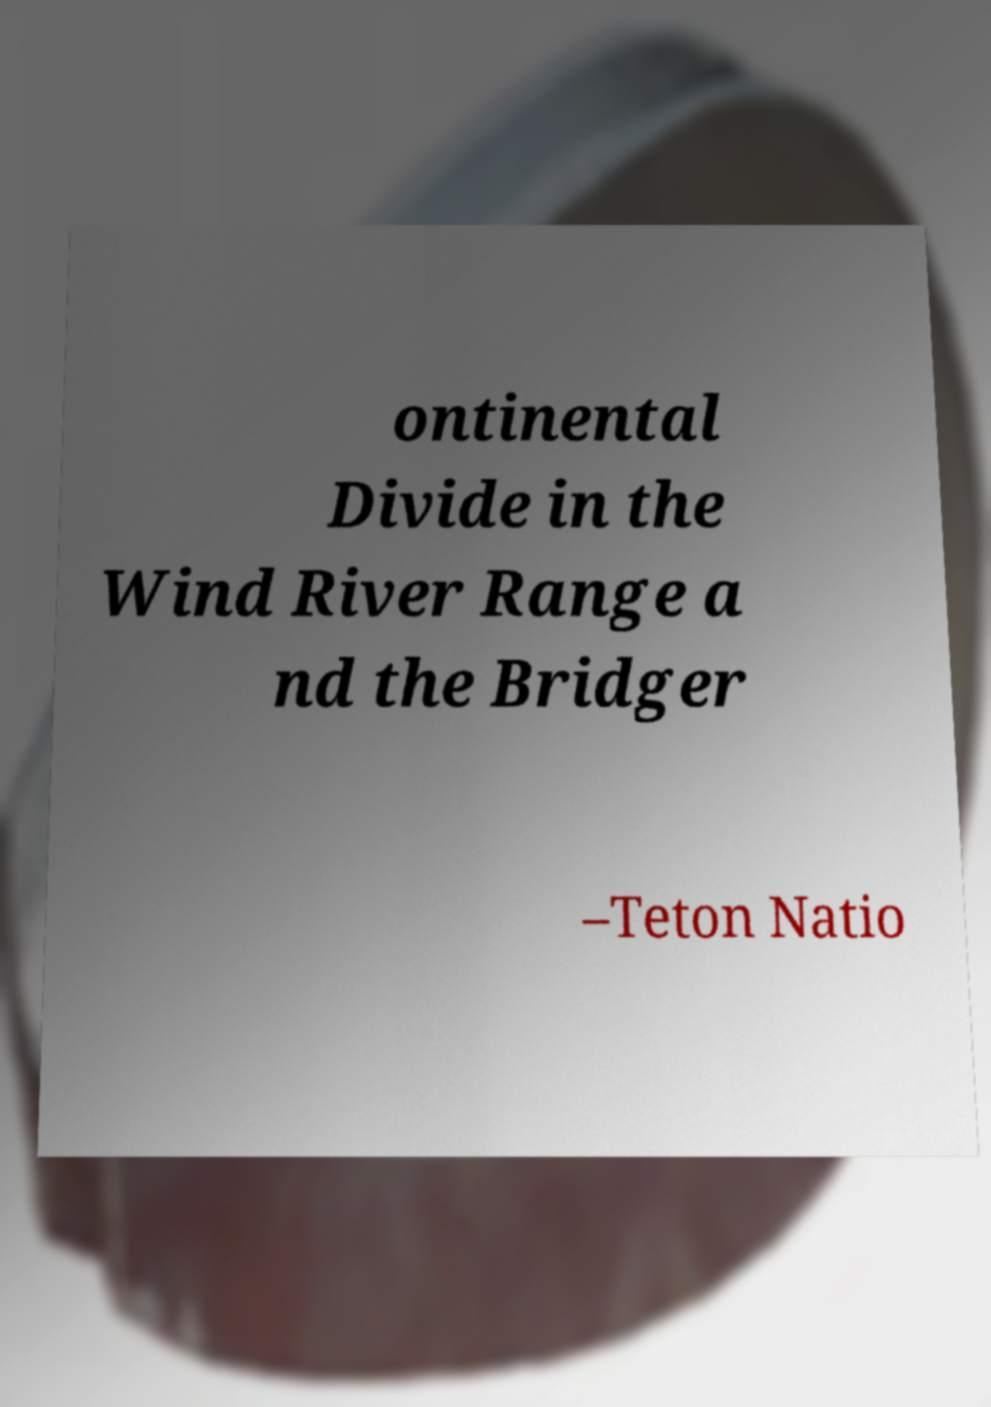Can you read and provide the text displayed in the image?This photo seems to have some interesting text. Can you extract and type it out for me? ontinental Divide in the Wind River Range a nd the Bridger –Teton Natio 